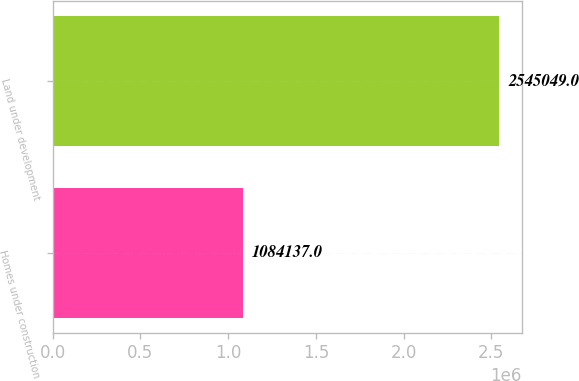<chart> <loc_0><loc_0><loc_500><loc_500><bar_chart><fcel>Homes under construction<fcel>Land under development<nl><fcel>1.08414e+06<fcel>2.54505e+06<nl></chart> 